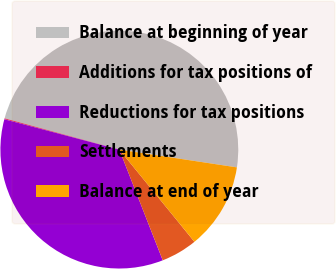<chart> <loc_0><loc_0><loc_500><loc_500><pie_chart><fcel>Balance at beginning of year<fcel>Additions for tax positions of<fcel>Reductions for tax positions<fcel>Settlements<fcel>Balance at end of year<nl><fcel>48.15%<fcel>0.13%<fcel>35.05%<fcel>4.93%<fcel>11.73%<nl></chart> 